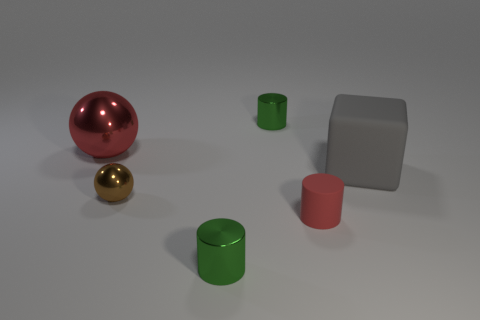What is the material of the tiny green object that is behind the tiny red thing? The tiny green object appears to be made of a plastic or ceramic material, characterized by its uniform, glossy surface and the way it reflects light. 